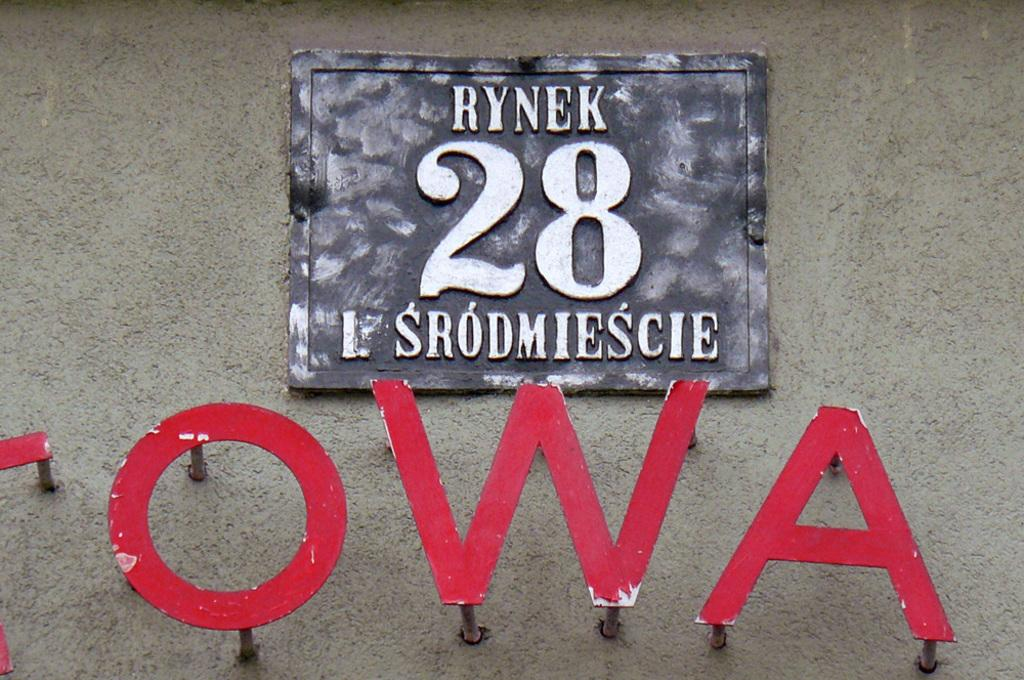What is the main object in the image? There is a stone board in the image. What is written on the stone board? The stone board has the number "twenty eight" written on it. What can be seen on the wall in the image? There are red color alphabets hanging on the wall in the image. What type of drum is being played in the image? There is no drum present in the image; it only features a stone board with the number "twenty eight" and red color alphabets on the wall. 